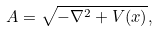Convert formula to latex. <formula><loc_0><loc_0><loc_500><loc_500>A = \sqrt { - \nabla ^ { 2 } + V ( x ) } ,</formula> 